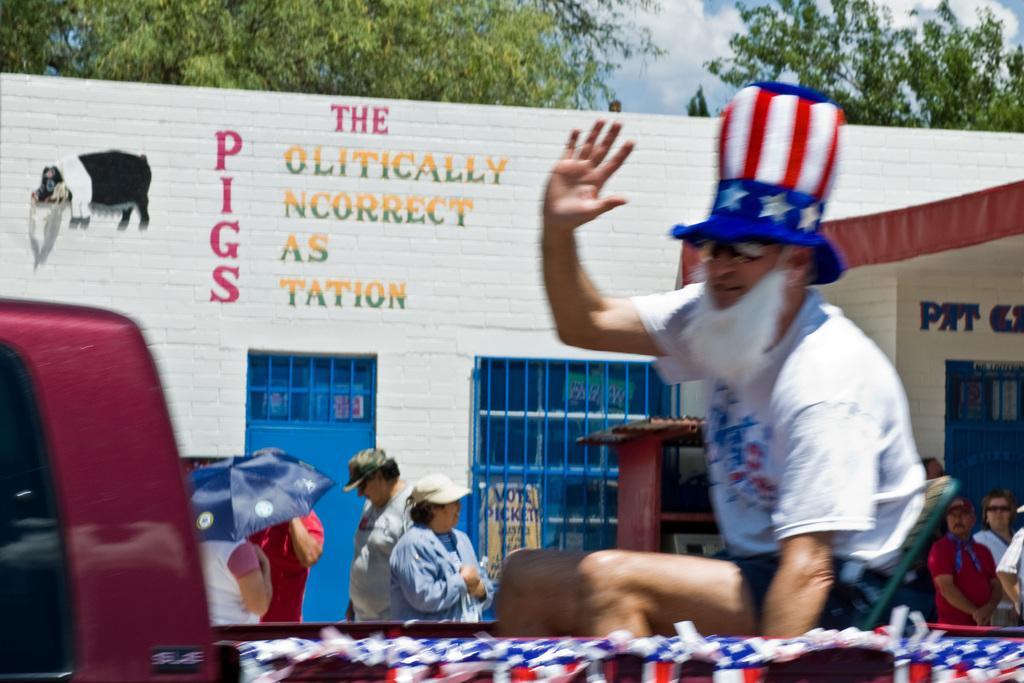Please provide a concise description of this image. In this image there are people. In the foreground there is a man sitting on a chair. He is wearing a cap. Behind him there is a building. There is text on the building. To the left there is picture of a pig on the walls of the building. At the top there are trees and the sky. 